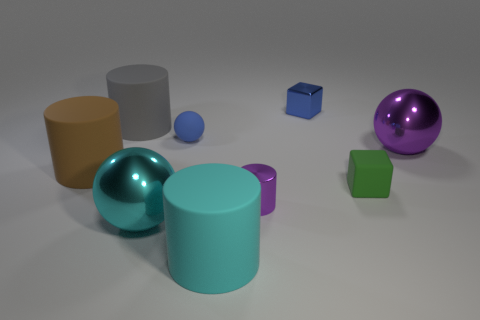How does the lighting in the image influence the appearance of the objects? The lighting in the image is soft and diffused, which creates gentle shadows and highlights on the objects. This highlights the unique surface textures and colors of each object, giving clues about the materials. For instance, the shiny spheres reflect the light, hinting at a possibly metallic or glossy plastic material, while the cylinders and cubes have more subdued reflections. 